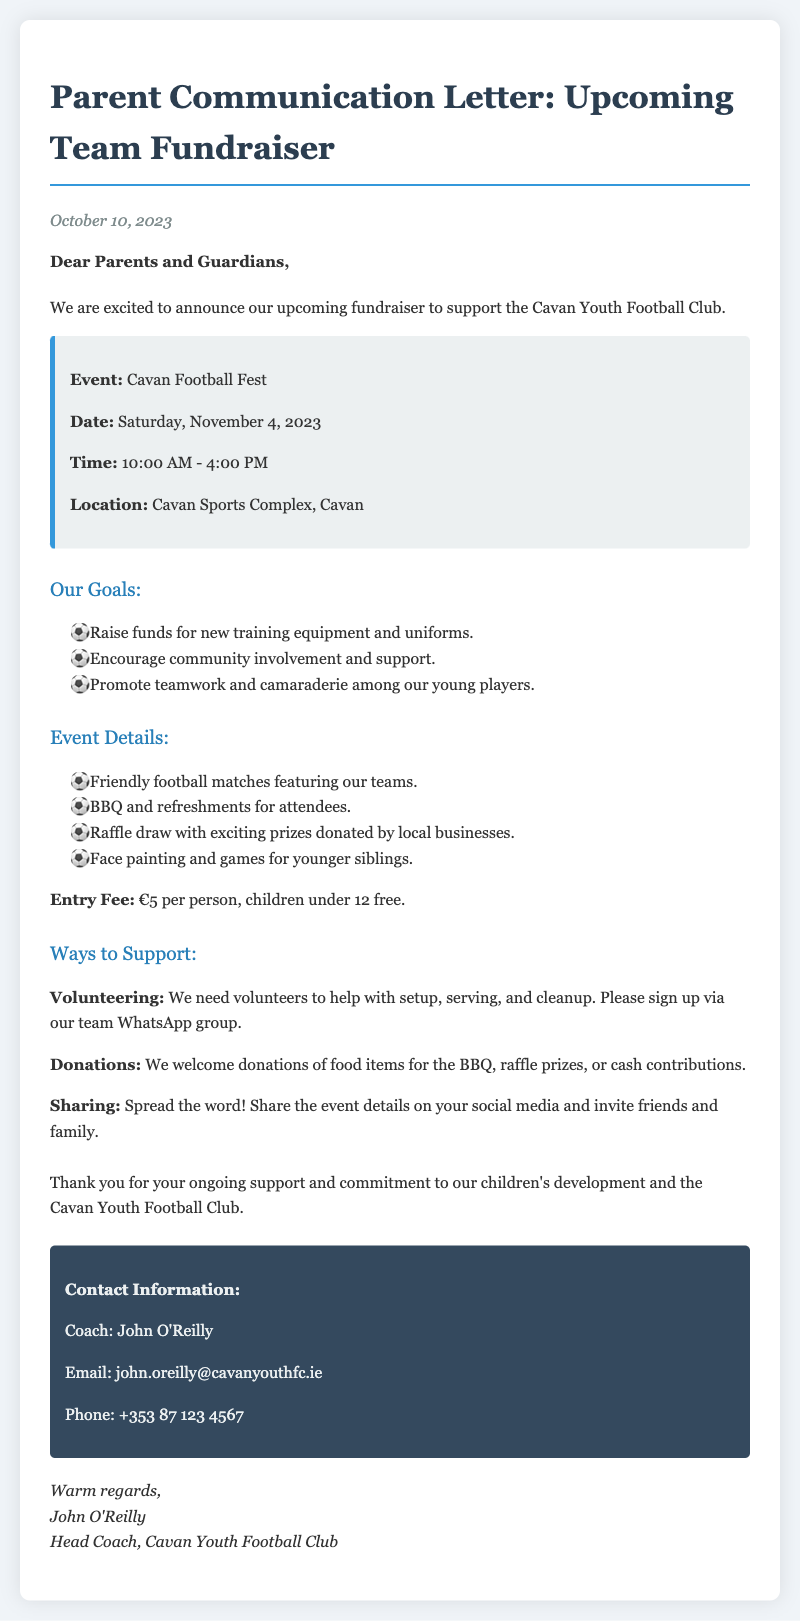What is the name of the fundraiser? The fundraiser is named "Cavan Football Fest" as stated in the event details.
Answer: Cavan Football Fest What is the date of the event? The event date is explicitly mentioned in the document as November 4, 2023.
Answer: November 4, 2023 What is the entry fee for the event? The entry fee is mentioned as €5 per person in the event details section.
Answer: €5 What items are needed for the BBQ? The document states that food item donations for the BBQ are welcome, indicating a need for food items.
Answer: Food items How long will the event last? The event starts at 10:00 AM and ends at 4:00 PM, which shows it lasts for 6 hours.
Answer: 6 hours Who should be contacted for more information? The contact person listed in the document for more information is Coach John O'Reilly.
Answer: John O'Reilly What is one of the goals for the fundraiser? One of the explicitly stated goals is to raise funds for new training equipment and uniforms.
Answer: New training equipment and uniforms What activities are included in the event? The document mentions friendly football matches, BBQ, raffle, face painting, and games as activities included in the event.
Answer: Friendly football matches, BBQ, raffle, face painting, games What is the age limit for free entry? The document specifies that children under 12 can enter for free, indicating the age limit.
Answer: Under 12 